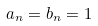<formula> <loc_0><loc_0><loc_500><loc_500>a _ { n } = b _ { n } = 1</formula> 